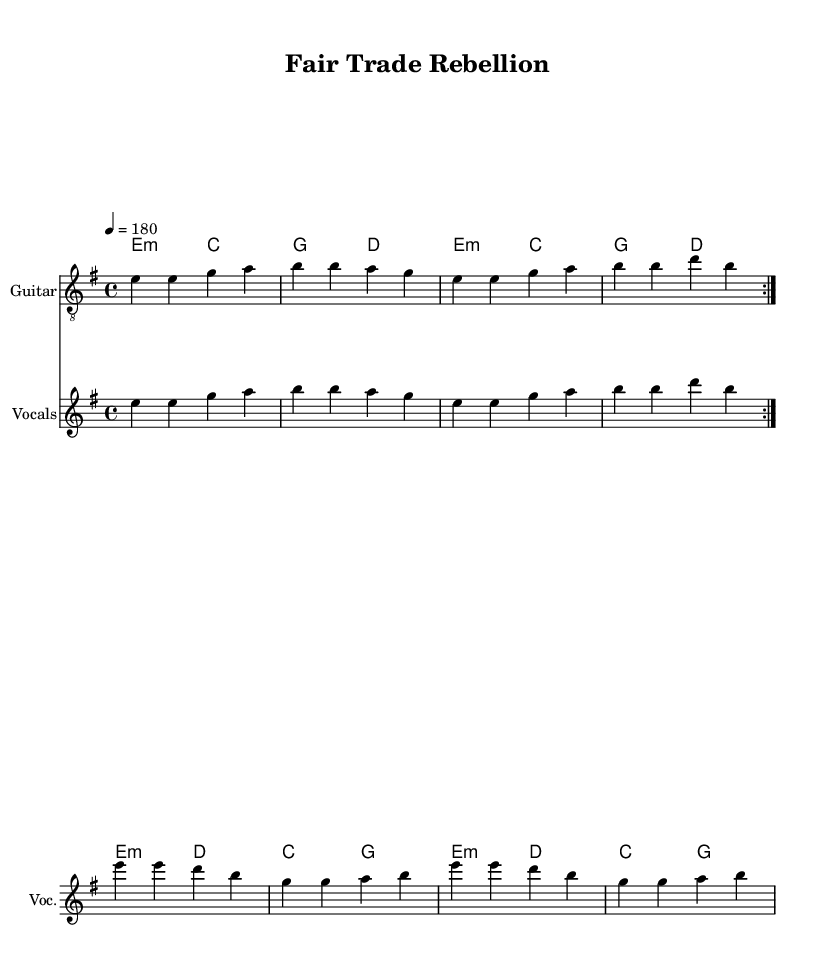What is the key signature of this music? The key signature is E minor, which has one sharp (F#) noted at the beginning of the score.
Answer: E minor What is the time signature of the music? The time signature is indicated as 4/4, which can be seen at the beginning of the score, indicating four beats per measure.
Answer: 4/4 What is the tempo marking for the piece? The tempo marking is 4 = 180, located in the global definitions section, indicating the speed of the music.
Answer: 180 How many times is the guitar riff repeated in the score? The guitar music indicates a repeat sign, specifically stating to repeat the section twice, which is indicated with the "volta" marking.
Answer: 2 What is the main theme of the lyrics? The lyrics discuss fair trade issues, breaking global trade imbalances, and promoting a sustainable future, which is a central message in anarcho-punk music.
Answer: Fair trade What is the structure of the lyrics? The lyrics are divided into a verse and a chorus, showcasing a typical song structure where the verse introduces the theme and the chorus emphasizes the main message.
Answer: Verse and chorus How can the chord progression be described? The chord progression alternates between E minor and G major chords, indicating a typical punk structure with a repetitive and straightforward harmonic movement.
Answer: E minor to G major 